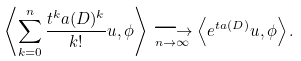Convert formula to latex. <formula><loc_0><loc_0><loc_500><loc_500>\left \langle \sum _ { k = 0 } ^ { n } \frac { t ^ { k } a ( D ) ^ { k } } { k ! } u , \phi \right \rangle \underset { n \to \infty } { \longrightarrow } \left \langle e ^ { t a ( D ) } u , \phi \right \rangle .</formula> 